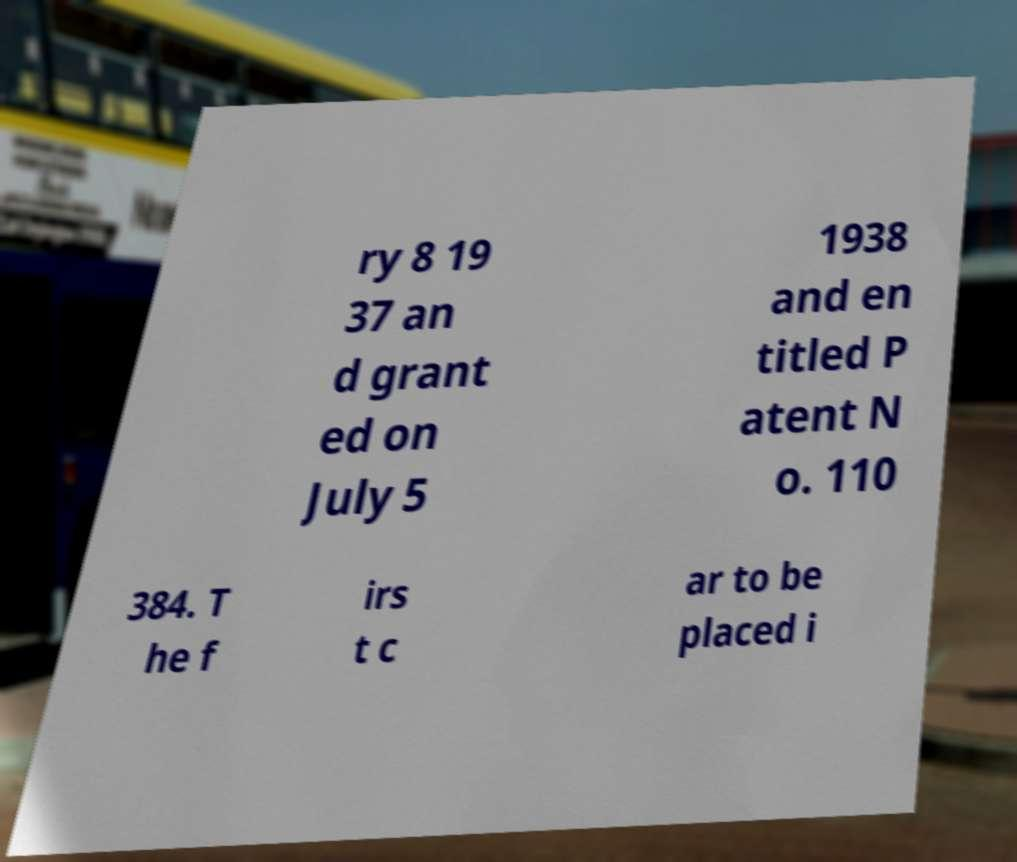Please identify and transcribe the text found in this image. ry 8 19 37 an d grant ed on July 5 1938 and en titled P atent N o. 110 384. T he f irs t c ar to be placed i 